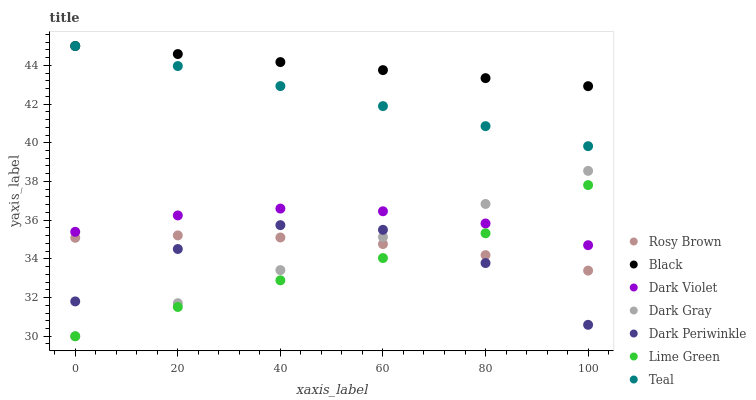Does Lime Green have the minimum area under the curve?
Answer yes or no. Yes. Does Black have the maximum area under the curve?
Answer yes or no. Yes. Does Dark Violet have the minimum area under the curve?
Answer yes or no. No. Does Dark Violet have the maximum area under the curve?
Answer yes or no. No. Is Teal the smoothest?
Answer yes or no. Yes. Is Dark Periwinkle the roughest?
Answer yes or no. Yes. Is Dark Violet the smoothest?
Answer yes or no. No. Is Dark Violet the roughest?
Answer yes or no. No. Does Dark Gray have the lowest value?
Answer yes or no. Yes. Does Dark Violet have the lowest value?
Answer yes or no. No. Does Teal have the highest value?
Answer yes or no. Yes. Does Dark Violet have the highest value?
Answer yes or no. No. Is Dark Violet less than Teal?
Answer yes or no. Yes. Is Black greater than Lime Green?
Answer yes or no. Yes. Does Dark Gray intersect Lime Green?
Answer yes or no. Yes. Is Dark Gray less than Lime Green?
Answer yes or no. No. Is Dark Gray greater than Lime Green?
Answer yes or no. No. Does Dark Violet intersect Teal?
Answer yes or no. No. 